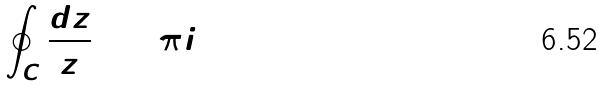<formula> <loc_0><loc_0><loc_500><loc_500>\oint _ { C } \frac { d z } { z } = 2 \pi i</formula> 